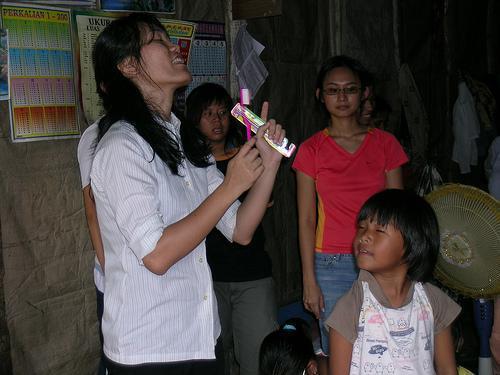How many little girls are in the picture?
Give a very brief answer. 1. How many women are wearing glasses?
Give a very brief answer. 1. How many toothbrushes is the woman holding?
Give a very brief answer. 1. 